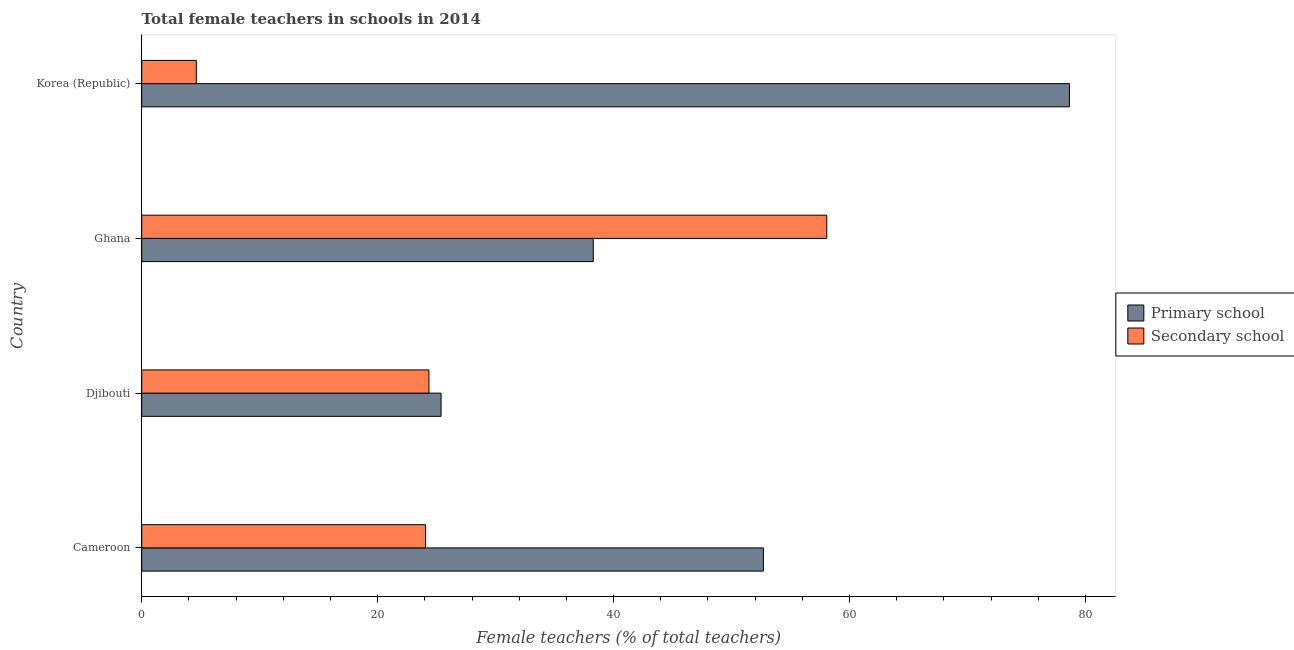How many different coloured bars are there?
Offer a terse response. 2. How many groups of bars are there?
Keep it short and to the point. 4. How many bars are there on the 2nd tick from the top?
Keep it short and to the point. 2. What is the label of the 2nd group of bars from the top?
Offer a terse response. Ghana. In how many cases, is the number of bars for a given country not equal to the number of legend labels?
Keep it short and to the point. 0. What is the percentage of female teachers in primary schools in Cameroon?
Your answer should be very brief. 52.7. Across all countries, what is the maximum percentage of female teachers in primary schools?
Make the answer very short. 78.64. Across all countries, what is the minimum percentage of female teachers in secondary schools?
Offer a very short reply. 4.63. In which country was the percentage of female teachers in primary schools minimum?
Offer a very short reply. Djibouti. What is the total percentage of female teachers in primary schools in the graph?
Provide a short and direct response. 194.99. What is the difference between the percentage of female teachers in primary schools in Cameroon and that in Korea (Republic)?
Offer a terse response. -25.94. What is the difference between the percentage of female teachers in secondary schools in Cameroon and the percentage of female teachers in primary schools in Ghana?
Your answer should be compact. -14.22. What is the average percentage of female teachers in secondary schools per country?
Your response must be concise. 27.77. What is the difference between the percentage of female teachers in primary schools and percentage of female teachers in secondary schools in Korea (Republic)?
Provide a short and direct response. 74.01. What is the ratio of the percentage of female teachers in secondary schools in Djibouti to that in Ghana?
Give a very brief answer. 0.42. Is the percentage of female teachers in primary schools in Cameroon less than that in Ghana?
Your answer should be very brief. No. Is the difference between the percentage of female teachers in primary schools in Cameroon and Ghana greater than the difference between the percentage of female teachers in secondary schools in Cameroon and Ghana?
Provide a short and direct response. Yes. What is the difference between the highest and the second highest percentage of female teachers in primary schools?
Offer a terse response. 25.94. What is the difference between the highest and the lowest percentage of female teachers in primary schools?
Your answer should be compact. 53.26. Is the sum of the percentage of female teachers in primary schools in Djibouti and Korea (Republic) greater than the maximum percentage of female teachers in secondary schools across all countries?
Provide a succinct answer. Yes. What does the 2nd bar from the top in Djibouti represents?
Offer a terse response. Primary school. What does the 1st bar from the bottom in Korea (Republic) represents?
Your response must be concise. Primary school. Are all the bars in the graph horizontal?
Offer a terse response. Yes. How many countries are there in the graph?
Provide a succinct answer. 4. Does the graph contain grids?
Your answer should be very brief. No. Where does the legend appear in the graph?
Your response must be concise. Center right. How many legend labels are there?
Make the answer very short. 2. What is the title of the graph?
Keep it short and to the point. Total female teachers in schools in 2014. Does "Diesel" appear as one of the legend labels in the graph?
Provide a short and direct response. No. What is the label or title of the X-axis?
Provide a succinct answer. Female teachers (% of total teachers). What is the label or title of the Y-axis?
Your response must be concise. Country. What is the Female teachers (% of total teachers) of Primary school in Cameroon?
Your response must be concise. 52.7. What is the Female teachers (% of total teachers) in Secondary school in Cameroon?
Give a very brief answer. 24.06. What is the Female teachers (% of total teachers) of Primary school in Djibouti?
Your answer should be very brief. 25.37. What is the Female teachers (% of total teachers) of Secondary school in Djibouti?
Your answer should be very brief. 24.35. What is the Female teachers (% of total teachers) of Primary school in Ghana?
Give a very brief answer. 38.28. What is the Female teachers (% of total teachers) of Secondary school in Ghana?
Give a very brief answer. 58.07. What is the Female teachers (% of total teachers) in Primary school in Korea (Republic)?
Provide a short and direct response. 78.64. What is the Female teachers (% of total teachers) in Secondary school in Korea (Republic)?
Your answer should be very brief. 4.63. Across all countries, what is the maximum Female teachers (% of total teachers) of Primary school?
Provide a short and direct response. 78.64. Across all countries, what is the maximum Female teachers (% of total teachers) in Secondary school?
Provide a short and direct response. 58.07. Across all countries, what is the minimum Female teachers (% of total teachers) in Primary school?
Make the answer very short. 25.37. Across all countries, what is the minimum Female teachers (% of total teachers) in Secondary school?
Give a very brief answer. 4.63. What is the total Female teachers (% of total teachers) in Primary school in the graph?
Your answer should be compact. 194.99. What is the total Female teachers (% of total teachers) in Secondary school in the graph?
Ensure brevity in your answer.  111.1. What is the difference between the Female teachers (% of total teachers) in Primary school in Cameroon and that in Djibouti?
Your answer should be very brief. 27.32. What is the difference between the Female teachers (% of total teachers) in Secondary school in Cameroon and that in Djibouti?
Offer a very short reply. -0.29. What is the difference between the Female teachers (% of total teachers) of Primary school in Cameroon and that in Ghana?
Your response must be concise. 14.42. What is the difference between the Female teachers (% of total teachers) of Secondary school in Cameroon and that in Ghana?
Provide a short and direct response. -34.01. What is the difference between the Female teachers (% of total teachers) of Primary school in Cameroon and that in Korea (Republic)?
Ensure brevity in your answer.  -25.94. What is the difference between the Female teachers (% of total teachers) of Secondary school in Cameroon and that in Korea (Republic)?
Your answer should be compact. 19.43. What is the difference between the Female teachers (% of total teachers) of Primary school in Djibouti and that in Ghana?
Ensure brevity in your answer.  -12.9. What is the difference between the Female teachers (% of total teachers) in Secondary school in Djibouti and that in Ghana?
Give a very brief answer. -33.72. What is the difference between the Female teachers (% of total teachers) in Primary school in Djibouti and that in Korea (Republic)?
Provide a short and direct response. -53.26. What is the difference between the Female teachers (% of total teachers) of Secondary school in Djibouti and that in Korea (Republic)?
Offer a very short reply. 19.72. What is the difference between the Female teachers (% of total teachers) of Primary school in Ghana and that in Korea (Republic)?
Keep it short and to the point. -40.36. What is the difference between the Female teachers (% of total teachers) of Secondary school in Ghana and that in Korea (Republic)?
Ensure brevity in your answer.  53.44. What is the difference between the Female teachers (% of total teachers) in Primary school in Cameroon and the Female teachers (% of total teachers) in Secondary school in Djibouti?
Offer a very short reply. 28.35. What is the difference between the Female teachers (% of total teachers) in Primary school in Cameroon and the Female teachers (% of total teachers) in Secondary school in Ghana?
Ensure brevity in your answer.  -5.37. What is the difference between the Female teachers (% of total teachers) of Primary school in Cameroon and the Female teachers (% of total teachers) of Secondary school in Korea (Republic)?
Offer a terse response. 48.07. What is the difference between the Female teachers (% of total teachers) of Primary school in Djibouti and the Female teachers (% of total teachers) of Secondary school in Ghana?
Provide a short and direct response. -32.69. What is the difference between the Female teachers (% of total teachers) in Primary school in Djibouti and the Female teachers (% of total teachers) in Secondary school in Korea (Republic)?
Your answer should be very brief. 20.75. What is the difference between the Female teachers (% of total teachers) of Primary school in Ghana and the Female teachers (% of total teachers) of Secondary school in Korea (Republic)?
Offer a terse response. 33.65. What is the average Female teachers (% of total teachers) of Primary school per country?
Provide a succinct answer. 48.75. What is the average Female teachers (% of total teachers) of Secondary school per country?
Provide a short and direct response. 27.77. What is the difference between the Female teachers (% of total teachers) in Primary school and Female teachers (% of total teachers) in Secondary school in Cameroon?
Your response must be concise. 28.64. What is the difference between the Female teachers (% of total teachers) in Primary school and Female teachers (% of total teachers) in Secondary school in Djibouti?
Ensure brevity in your answer.  1.03. What is the difference between the Female teachers (% of total teachers) in Primary school and Female teachers (% of total teachers) in Secondary school in Ghana?
Keep it short and to the point. -19.79. What is the difference between the Female teachers (% of total teachers) in Primary school and Female teachers (% of total teachers) in Secondary school in Korea (Republic)?
Your response must be concise. 74.01. What is the ratio of the Female teachers (% of total teachers) in Primary school in Cameroon to that in Djibouti?
Your response must be concise. 2.08. What is the ratio of the Female teachers (% of total teachers) of Primary school in Cameroon to that in Ghana?
Keep it short and to the point. 1.38. What is the ratio of the Female teachers (% of total teachers) of Secondary school in Cameroon to that in Ghana?
Ensure brevity in your answer.  0.41. What is the ratio of the Female teachers (% of total teachers) of Primary school in Cameroon to that in Korea (Republic)?
Offer a terse response. 0.67. What is the ratio of the Female teachers (% of total teachers) in Secondary school in Cameroon to that in Korea (Republic)?
Offer a terse response. 5.2. What is the ratio of the Female teachers (% of total teachers) in Primary school in Djibouti to that in Ghana?
Your response must be concise. 0.66. What is the ratio of the Female teachers (% of total teachers) of Secondary school in Djibouti to that in Ghana?
Offer a terse response. 0.42. What is the ratio of the Female teachers (% of total teachers) in Primary school in Djibouti to that in Korea (Republic)?
Offer a terse response. 0.32. What is the ratio of the Female teachers (% of total teachers) of Secondary school in Djibouti to that in Korea (Republic)?
Your response must be concise. 5.26. What is the ratio of the Female teachers (% of total teachers) in Primary school in Ghana to that in Korea (Republic)?
Provide a short and direct response. 0.49. What is the ratio of the Female teachers (% of total teachers) of Secondary school in Ghana to that in Korea (Republic)?
Your response must be concise. 12.55. What is the difference between the highest and the second highest Female teachers (% of total teachers) in Primary school?
Offer a terse response. 25.94. What is the difference between the highest and the second highest Female teachers (% of total teachers) of Secondary school?
Give a very brief answer. 33.72. What is the difference between the highest and the lowest Female teachers (% of total teachers) of Primary school?
Keep it short and to the point. 53.26. What is the difference between the highest and the lowest Female teachers (% of total teachers) of Secondary school?
Your answer should be very brief. 53.44. 